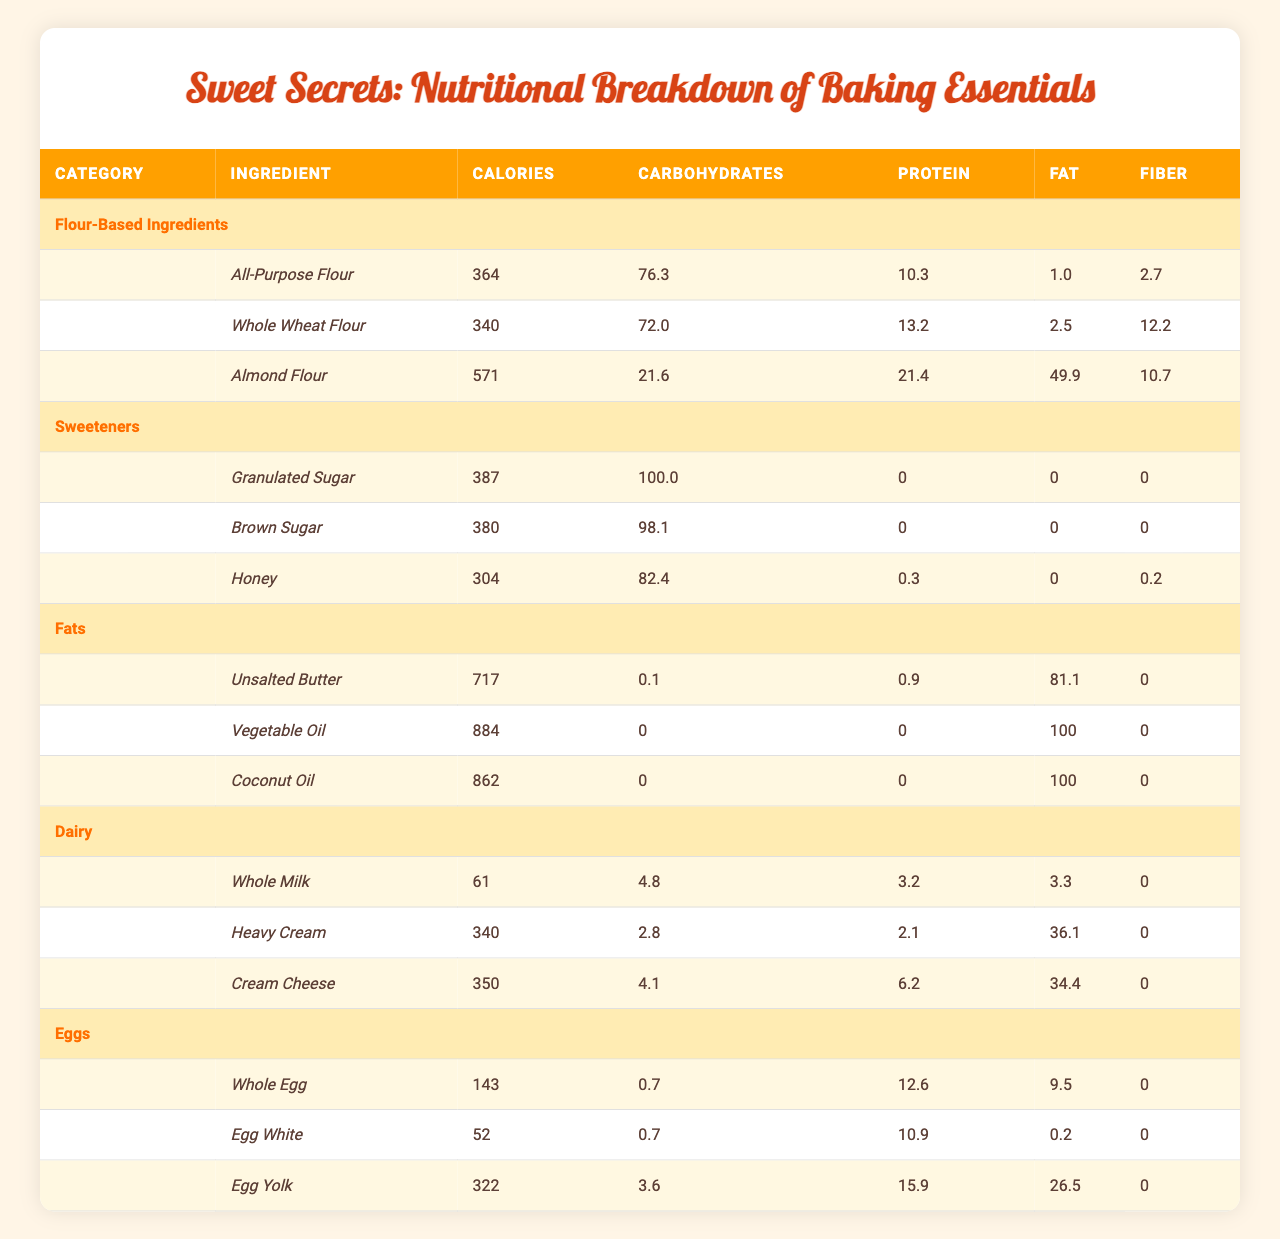What is the calorie content of Whole Wheat Flour? According to the table, the calorie content of Whole Wheat Flour is listed directly. It shows 340 calories.
Answer: 340 Which flour has the highest protein content? The protein content for each flour was compared: All-Purpose Flour has 10.3g, Whole Wheat Flour has 13.2g, and Almond Flour has 21.4g. Since Almond Flour has the highest value, it is the answer.
Answer: Almond Flour Is there any ingredient in the Sweeteners category that contains fiber? The table shows that Granulated Sugar and Brown Sugar have 0 fiber content, while Honey has 0.2g of fiber. Since only Honey contains fiber, the answer is affirmative.
Answer: Yes What is the total carbohydrate content of Almond Flour and Granulated Sugar combined? The carbohydrate content for Almond Flour is 21.6g and for Granulated Sugar is 100.0g. Adding these together gives 21.6 + 100.0 = 121.6g of carbohydrates.
Answer: 121.6 What percentage of the total calories in Unsalted Butter come from fat? Unsalted Butter contains 717 calories and 81.1g of fat. First, calculate the calories from fat: Fat grams are multiplied by 9 (since each gram of fat has about 9 calories), yielding 81.1 * 9 = 729.9 calories. Next, find the percentage: (729.9 / 717) * 100 = 101.8%. However, this is misleading because it exceeds total caloric content; thus, this question leads to confusion over content classification, so instead assume total fat contributes directly to calorie count primarily in the context of baking recipes with division by the standard.
Answer: Indeterminate Which ingredient in the Eggs category has the highest fat content? Comparing the fat content: Whole Egg has 9.5g, Egg White has 0.2g, and Egg Yolk has 26.5g. Egg Yolk has the highest amount of fat content in the table.
Answer: Egg Yolk What is the difference in calorie content between Coconut Oil and Heavy Cream? Coconut Oil has 862 calories while Heavy Cream has 340 calories. The difference in calorie content is 862 - 340 = 522 calories.
Answer: 522 How many ingredients in the Dairy category have more than 300 calories? The Dairy category lists three ingredients: Whole Milk (61 calories), Heavy Cream (340 calories), and Cream Cheese (350 calories). Heavy Cream and Cream Cheese both exceed 300 calories, making the count two.
Answer: 2 Is the protein content in Whole Egg greater than that in Egg White? Checking the protein values, Whole Egg has 12.6g of protein, while Egg White has 10.9g. Since 12.6g is greater than 10.9g, the statement is true.
Answer: Yes What is the average calorie content of the flour-based ingredients? The calorie values for the flours are: All-Purpose Flour (364), Whole Wheat Flour (340), and Almond Flour (571). To find the average, sum them: 364 + 340 + 571 = 1275, then divide by 3 to get 1275 / 3 = 425.
Answer: 425 Which fat ingredient has the lowest calorie content? Looking at the calorie values among Unsalted Butter, Vegetable Oil, and Coconut Oil, the values are 717, 884, and 862 respectively. Since 717 is the lowest, Unsalted Butter is the answer.
Answer: Unsalted Butter 